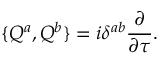<formula> <loc_0><loc_0><loc_500><loc_500>\{ Q ^ { a } , Q ^ { b } \} = i \delta ^ { a b } \frac { \partial } { \partial \tau } .</formula> 